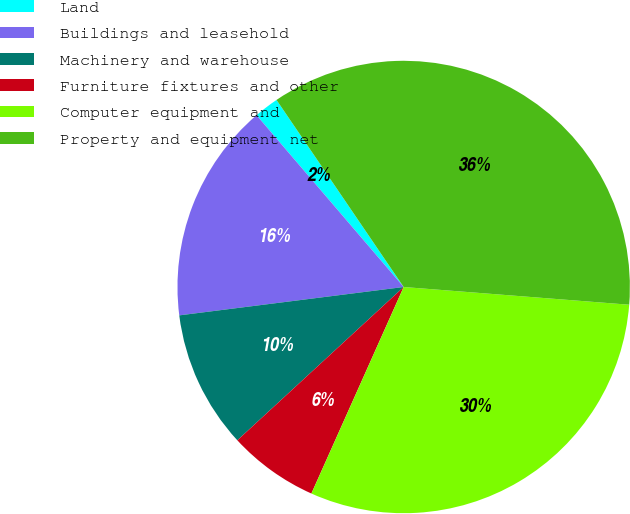Convert chart. <chart><loc_0><loc_0><loc_500><loc_500><pie_chart><fcel>Land<fcel>Buildings and leasehold<fcel>Machinery and warehouse<fcel>Furniture fixtures and other<fcel>Computer equipment and<fcel>Property and equipment net<nl><fcel>1.77%<fcel>15.73%<fcel>9.85%<fcel>6.46%<fcel>30.44%<fcel>35.75%<nl></chart> 